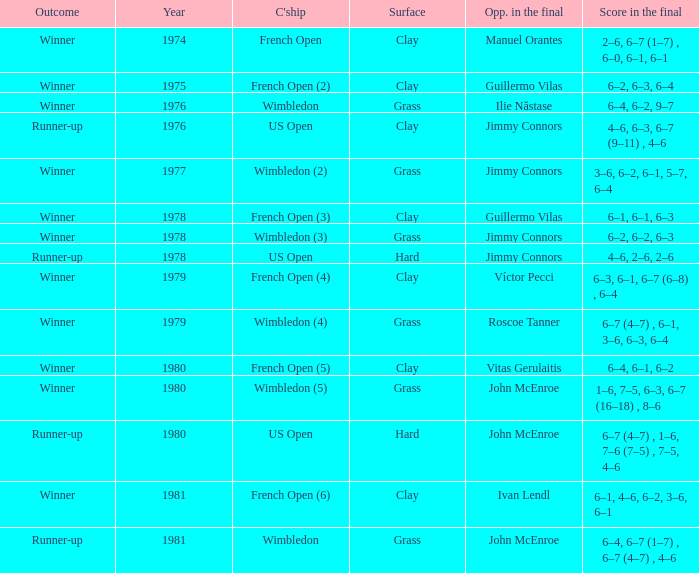What is every year where opponent in the final is John Mcenroe at Wimbledon? 1981.0. 